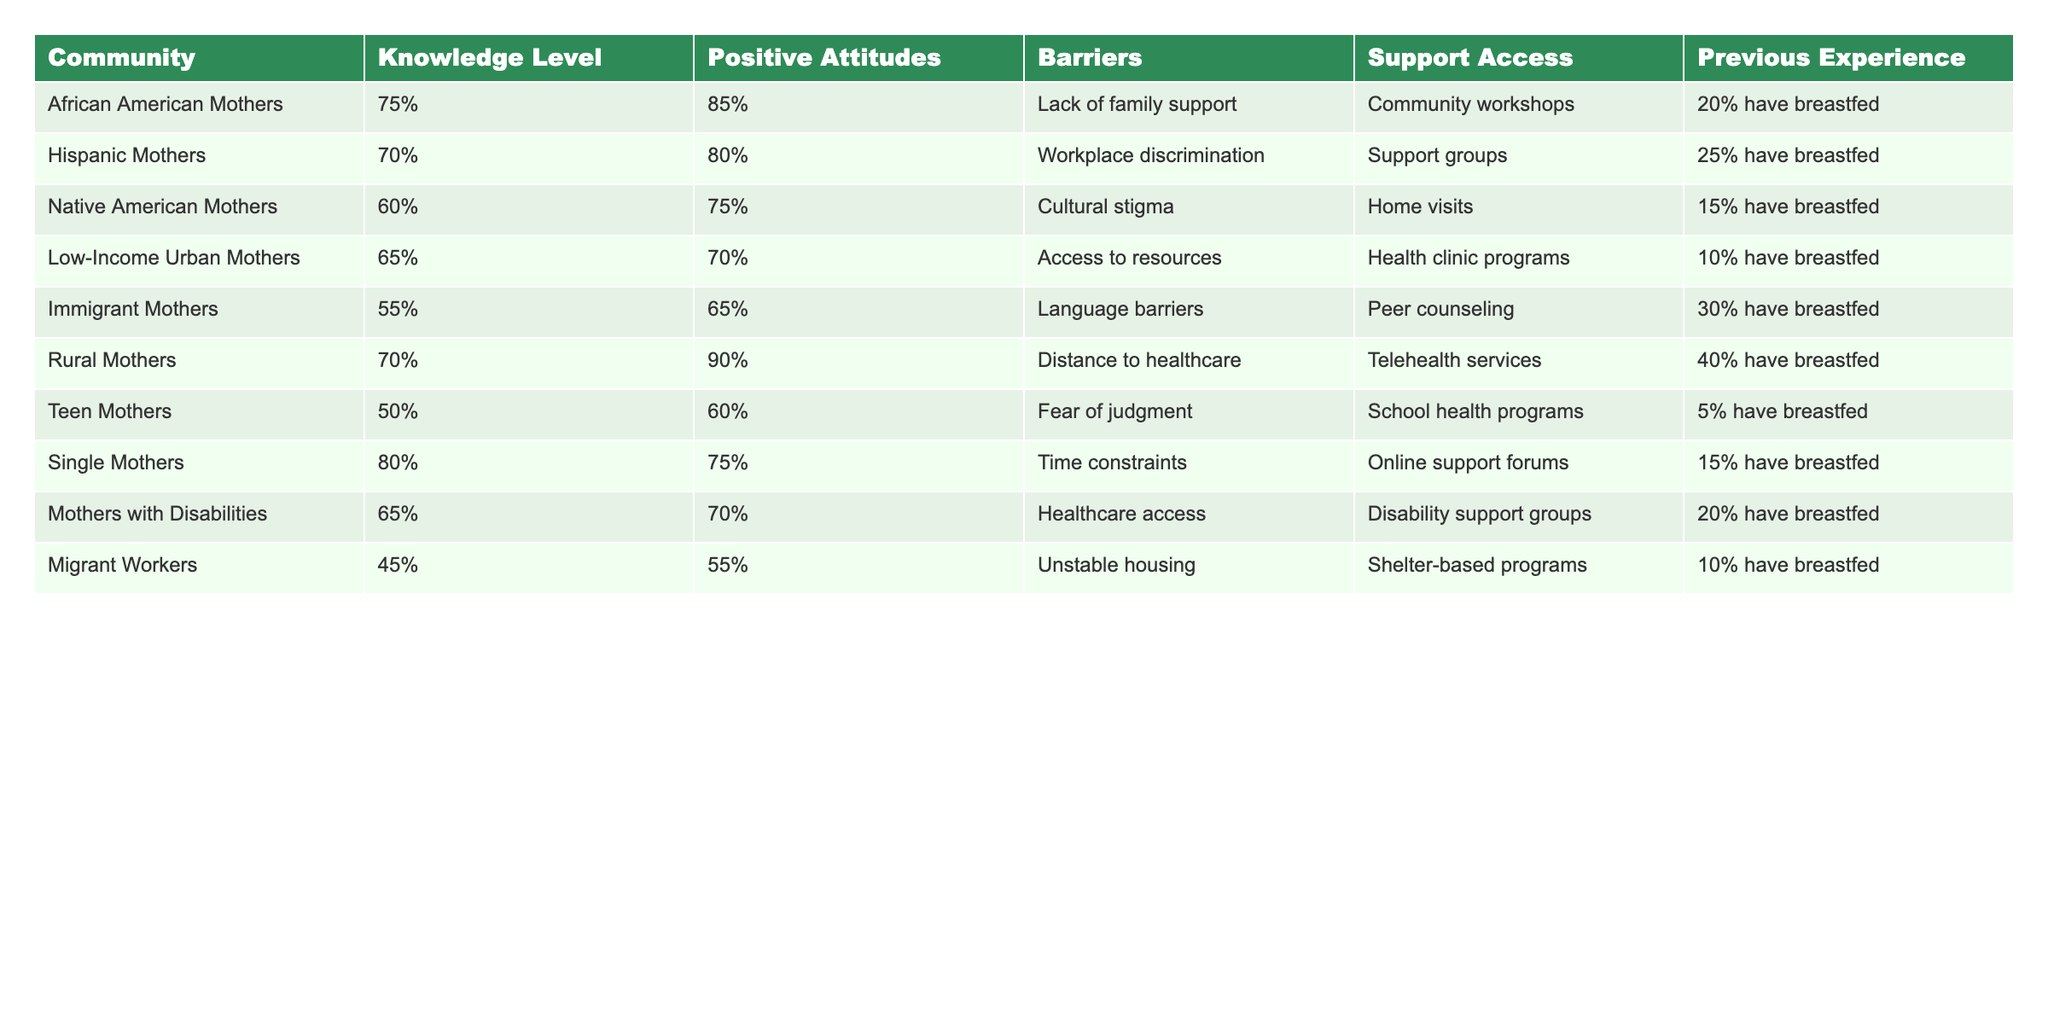What is the knowledge level of African American Mothers? The table states that the knowledge level for African American Mothers is 75%.
Answer: 75% Which community has the highest percentage of positive attitudes towards breastfeeding? By comparing the positive attitudes percentages, Rural Mothers have the highest at 90%.
Answer: 90% What are the barriers faced by Teen Mothers? The table indicates that Teen Mothers face the barrier of fear of judgment.
Answer: Fear of judgment What is the average knowledge level of all communities listed? The knowledge levels are 75%, 70%, 60%, 65%, 55%, 70%, 50%, 80%, 65%, and 45%. The sum is 725%. Dividing by 10 gives an average of 72.5%.
Answer: 72.5% Is there a community with 100% previous breastfeeding experience? The table does not show any community with 100% previous breastfeeding experience since the highest is 40% for Rural Mothers.
Answer: No Which community has the lowest percentage of mothers who have breastfed? The data shows that Teen Mothers have the lowest percentage, at 5%.
Answer: 5% What percentage of Immigrant Mothers have a positive attitude towards breastfeeding? According to the table, Immigrant Mothers have a positive attitude percentage of 65%.
Answer: 65% How many communities face barriers related to support access? The table lists six communities with varying barriers to support access, indicating that most have specific programs to support breastfeeding.
Answer: 6 What is the difference in the knowledge level between Low-Income Urban Mothers and Migrant Workers? The knowledge level for Low-Income Urban Mothers is 65% and for Migrant Workers, it is 45%. The difference is 65% - 45% = 20%.
Answer: 20% Which community has the highest previous breastfeeding experience and what is that percentage? Rural Mothers hold the highest previous breastfeeding experience at 40%.
Answer: 40% 